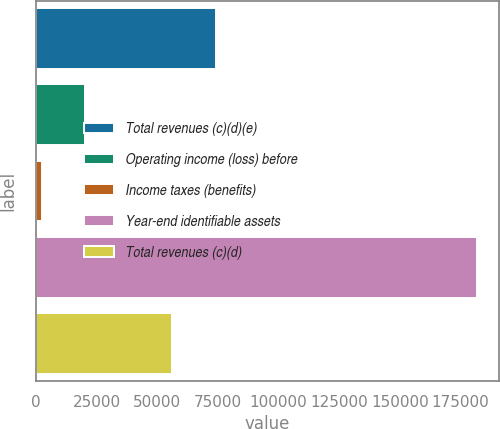Convert chart to OTSL. <chart><loc_0><loc_0><loc_500><loc_500><bar_chart><fcel>Total revenues (c)(d)(e)<fcel>Operating income (loss) before<fcel>Income taxes (benefits)<fcel>Year-end identifiable assets<fcel>Total revenues (c)(d)<nl><fcel>74119<fcel>20324.5<fcel>2393<fcel>181708<fcel>56187.5<nl></chart> 